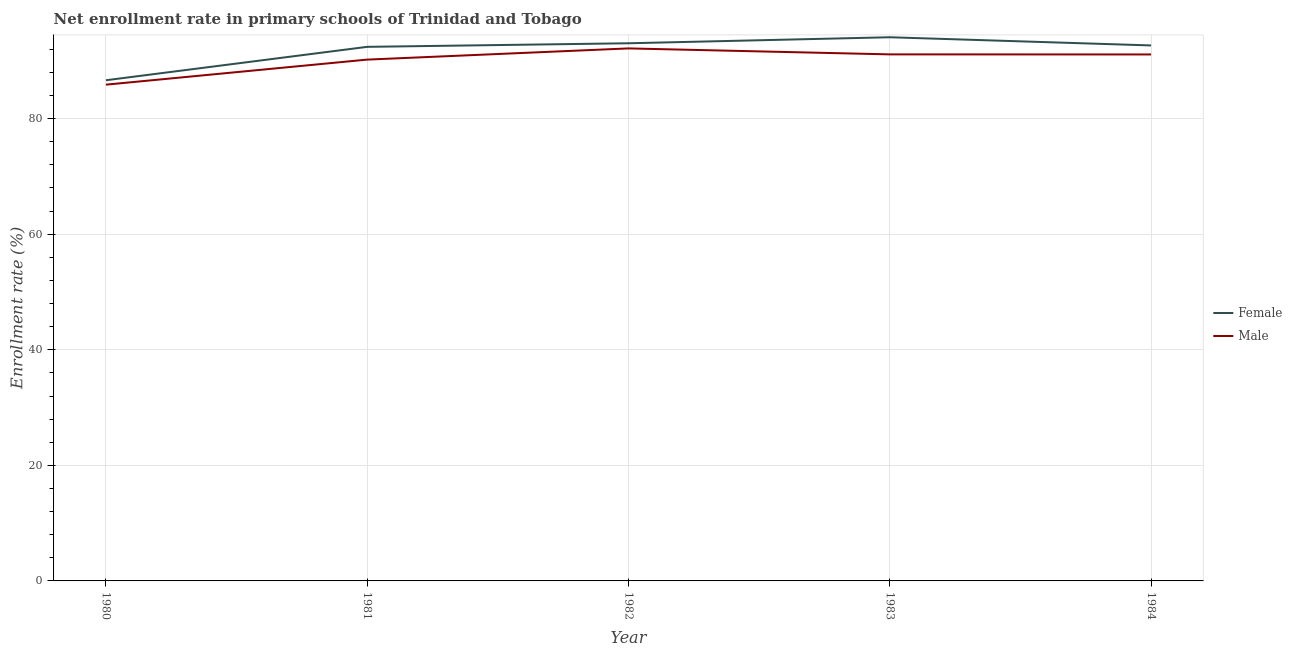What is the enrollment rate of female students in 1980?
Your answer should be compact. 86.64. Across all years, what is the maximum enrollment rate of male students?
Give a very brief answer. 92.15. Across all years, what is the minimum enrollment rate of female students?
Keep it short and to the point. 86.64. What is the total enrollment rate of female students in the graph?
Give a very brief answer. 458.85. What is the difference between the enrollment rate of male students in 1983 and that in 1984?
Give a very brief answer. 0.01. What is the difference between the enrollment rate of female students in 1982 and the enrollment rate of male students in 1984?
Ensure brevity in your answer.  1.93. What is the average enrollment rate of female students per year?
Your response must be concise. 91.77. In the year 1982, what is the difference between the enrollment rate of female students and enrollment rate of male students?
Offer a terse response. 0.89. In how many years, is the enrollment rate of male students greater than 40 %?
Your answer should be very brief. 5. What is the ratio of the enrollment rate of female students in 1981 to that in 1982?
Make the answer very short. 0.99. What is the difference between the highest and the second highest enrollment rate of male students?
Provide a succinct answer. 1.03. What is the difference between the highest and the lowest enrollment rate of female students?
Provide a short and direct response. 7.44. In how many years, is the enrollment rate of male students greater than the average enrollment rate of male students taken over all years?
Keep it short and to the point. 4. Does the enrollment rate of female students monotonically increase over the years?
Your answer should be compact. No. Is the enrollment rate of male students strictly less than the enrollment rate of female students over the years?
Ensure brevity in your answer.  Yes. How many lines are there?
Make the answer very short. 2. How many years are there in the graph?
Provide a short and direct response. 5. What is the difference between two consecutive major ticks on the Y-axis?
Make the answer very short. 20. Does the graph contain grids?
Your answer should be very brief. Yes. How are the legend labels stacked?
Offer a very short reply. Vertical. What is the title of the graph?
Make the answer very short. Net enrollment rate in primary schools of Trinidad and Tobago. Does "Highest 10% of population" appear as one of the legend labels in the graph?
Offer a very short reply. No. What is the label or title of the Y-axis?
Offer a terse response. Enrollment rate (%). What is the Enrollment rate (%) in Female in 1980?
Provide a short and direct response. 86.64. What is the Enrollment rate (%) in Male in 1980?
Provide a succinct answer. 85.88. What is the Enrollment rate (%) in Female in 1981?
Give a very brief answer. 92.42. What is the Enrollment rate (%) in Male in 1981?
Offer a very short reply. 90.21. What is the Enrollment rate (%) in Female in 1982?
Your answer should be very brief. 93.04. What is the Enrollment rate (%) of Male in 1982?
Provide a short and direct response. 92.15. What is the Enrollment rate (%) in Female in 1983?
Ensure brevity in your answer.  94.08. What is the Enrollment rate (%) in Male in 1983?
Offer a terse response. 91.12. What is the Enrollment rate (%) in Female in 1984?
Provide a short and direct response. 92.66. What is the Enrollment rate (%) in Male in 1984?
Give a very brief answer. 91.11. Across all years, what is the maximum Enrollment rate (%) of Female?
Your answer should be compact. 94.08. Across all years, what is the maximum Enrollment rate (%) of Male?
Your response must be concise. 92.15. Across all years, what is the minimum Enrollment rate (%) in Female?
Offer a terse response. 86.64. Across all years, what is the minimum Enrollment rate (%) in Male?
Give a very brief answer. 85.88. What is the total Enrollment rate (%) of Female in the graph?
Offer a very short reply. 458.85. What is the total Enrollment rate (%) in Male in the graph?
Keep it short and to the point. 450.46. What is the difference between the Enrollment rate (%) in Female in 1980 and that in 1981?
Your response must be concise. -5.78. What is the difference between the Enrollment rate (%) in Male in 1980 and that in 1981?
Give a very brief answer. -4.34. What is the difference between the Enrollment rate (%) of Female in 1980 and that in 1982?
Give a very brief answer. -6.4. What is the difference between the Enrollment rate (%) in Male in 1980 and that in 1982?
Your response must be concise. -6.27. What is the difference between the Enrollment rate (%) of Female in 1980 and that in 1983?
Give a very brief answer. -7.44. What is the difference between the Enrollment rate (%) in Male in 1980 and that in 1983?
Ensure brevity in your answer.  -5.24. What is the difference between the Enrollment rate (%) in Female in 1980 and that in 1984?
Provide a short and direct response. -6.02. What is the difference between the Enrollment rate (%) of Male in 1980 and that in 1984?
Keep it short and to the point. -5.23. What is the difference between the Enrollment rate (%) of Female in 1981 and that in 1982?
Offer a terse response. -0.62. What is the difference between the Enrollment rate (%) in Male in 1981 and that in 1982?
Ensure brevity in your answer.  -1.94. What is the difference between the Enrollment rate (%) of Female in 1981 and that in 1983?
Your response must be concise. -1.66. What is the difference between the Enrollment rate (%) of Male in 1981 and that in 1983?
Offer a very short reply. -0.91. What is the difference between the Enrollment rate (%) of Female in 1981 and that in 1984?
Your response must be concise. -0.24. What is the difference between the Enrollment rate (%) of Male in 1981 and that in 1984?
Your answer should be very brief. -0.89. What is the difference between the Enrollment rate (%) of Female in 1982 and that in 1983?
Provide a succinct answer. -1.04. What is the difference between the Enrollment rate (%) of Male in 1982 and that in 1983?
Provide a succinct answer. 1.03. What is the difference between the Enrollment rate (%) in Female in 1982 and that in 1984?
Ensure brevity in your answer.  0.38. What is the difference between the Enrollment rate (%) of Male in 1982 and that in 1984?
Your response must be concise. 1.05. What is the difference between the Enrollment rate (%) in Female in 1983 and that in 1984?
Make the answer very short. 1.42. What is the difference between the Enrollment rate (%) of Male in 1983 and that in 1984?
Offer a terse response. 0.01. What is the difference between the Enrollment rate (%) of Female in 1980 and the Enrollment rate (%) of Male in 1981?
Give a very brief answer. -3.57. What is the difference between the Enrollment rate (%) in Female in 1980 and the Enrollment rate (%) in Male in 1982?
Offer a terse response. -5.51. What is the difference between the Enrollment rate (%) of Female in 1980 and the Enrollment rate (%) of Male in 1983?
Provide a short and direct response. -4.48. What is the difference between the Enrollment rate (%) in Female in 1980 and the Enrollment rate (%) in Male in 1984?
Keep it short and to the point. -4.46. What is the difference between the Enrollment rate (%) of Female in 1981 and the Enrollment rate (%) of Male in 1982?
Your response must be concise. 0.27. What is the difference between the Enrollment rate (%) in Female in 1981 and the Enrollment rate (%) in Male in 1983?
Make the answer very short. 1.3. What is the difference between the Enrollment rate (%) of Female in 1981 and the Enrollment rate (%) of Male in 1984?
Keep it short and to the point. 1.32. What is the difference between the Enrollment rate (%) in Female in 1982 and the Enrollment rate (%) in Male in 1983?
Ensure brevity in your answer.  1.92. What is the difference between the Enrollment rate (%) in Female in 1982 and the Enrollment rate (%) in Male in 1984?
Your response must be concise. 1.93. What is the difference between the Enrollment rate (%) in Female in 1983 and the Enrollment rate (%) in Male in 1984?
Provide a short and direct response. 2.98. What is the average Enrollment rate (%) of Female per year?
Make the answer very short. 91.77. What is the average Enrollment rate (%) in Male per year?
Offer a terse response. 90.09. In the year 1980, what is the difference between the Enrollment rate (%) in Female and Enrollment rate (%) in Male?
Provide a short and direct response. 0.76. In the year 1981, what is the difference between the Enrollment rate (%) in Female and Enrollment rate (%) in Male?
Provide a succinct answer. 2.21. In the year 1982, what is the difference between the Enrollment rate (%) in Female and Enrollment rate (%) in Male?
Make the answer very short. 0.89. In the year 1983, what is the difference between the Enrollment rate (%) in Female and Enrollment rate (%) in Male?
Offer a terse response. 2.96. In the year 1984, what is the difference between the Enrollment rate (%) of Female and Enrollment rate (%) of Male?
Keep it short and to the point. 1.56. What is the ratio of the Enrollment rate (%) of Female in 1980 to that in 1981?
Give a very brief answer. 0.94. What is the ratio of the Enrollment rate (%) in Male in 1980 to that in 1981?
Provide a succinct answer. 0.95. What is the ratio of the Enrollment rate (%) of Female in 1980 to that in 1982?
Your answer should be very brief. 0.93. What is the ratio of the Enrollment rate (%) of Male in 1980 to that in 1982?
Your answer should be compact. 0.93. What is the ratio of the Enrollment rate (%) of Female in 1980 to that in 1983?
Ensure brevity in your answer.  0.92. What is the ratio of the Enrollment rate (%) of Male in 1980 to that in 1983?
Your answer should be very brief. 0.94. What is the ratio of the Enrollment rate (%) of Female in 1980 to that in 1984?
Your answer should be very brief. 0.94. What is the ratio of the Enrollment rate (%) of Male in 1980 to that in 1984?
Provide a short and direct response. 0.94. What is the ratio of the Enrollment rate (%) in Female in 1981 to that in 1982?
Provide a succinct answer. 0.99. What is the ratio of the Enrollment rate (%) in Female in 1981 to that in 1983?
Your answer should be compact. 0.98. What is the ratio of the Enrollment rate (%) of Male in 1981 to that in 1983?
Give a very brief answer. 0.99. What is the ratio of the Enrollment rate (%) in Female in 1981 to that in 1984?
Provide a succinct answer. 1. What is the ratio of the Enrollment rate (%) of Male in 1981 to that in 1984?
Give a very brief answer. 0.99. What is the ratio of the Enrollment rate (%) of Female in 1982 to that in 1983?
Keep it short and to the point. 0.99. What is the ratio of the Enrollment rate (%) in Male in 1982 to that in 1983?
Keep it short and to the point. 1.01. What is the ratio of the Enrollment rate (%) in Male in 1982 to that in 1984?
Keep it short and to the point. 1.01. What is the ratio of the Enrollment rate (%) in Female in 1983 to that in 1984?
Ensure brevity in your answer.  1.02. What is the ratio of the Enrollment rate (%) of Male in 1983 to that in 1984?
Provide a succinct answer. 1. What is the difference between the highest and the second highest Enrollment rate (%) in Female?
Offer a terse response. 1.04. What is the difference between the highest and the second highest Enrollment rate (%) of Male?
Your answer should be compact. 1.03. What is the difference between the highest and the lowest Enrollment rate (%) in Female?
Your response must be concise. 7.44. What is the difference between the highest and the lowest Enrollment rate (%) in Male?
Offer a very short reply. 6.27. 